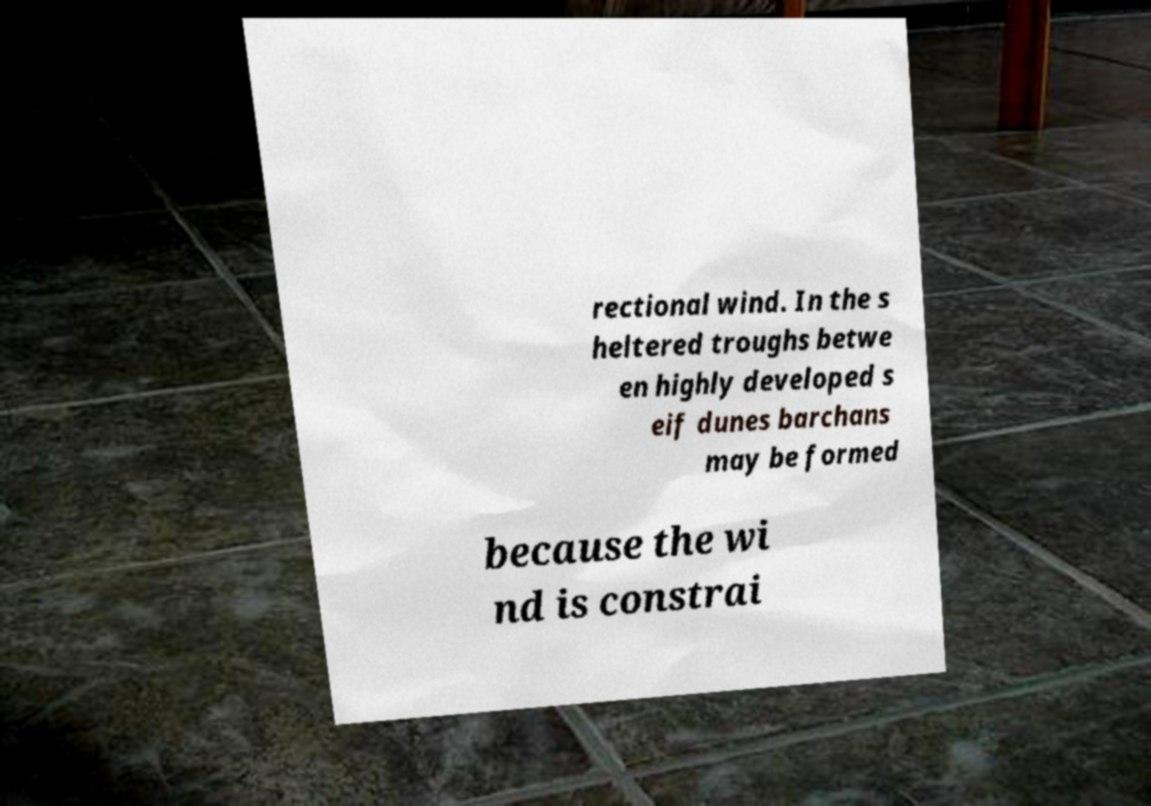Can you accurately transcribe the text from the provided image for me? rectional wind. In the s heltered troughs betwe en highly developed s eif dunes barchans may be formed because the wi nd is constrai 